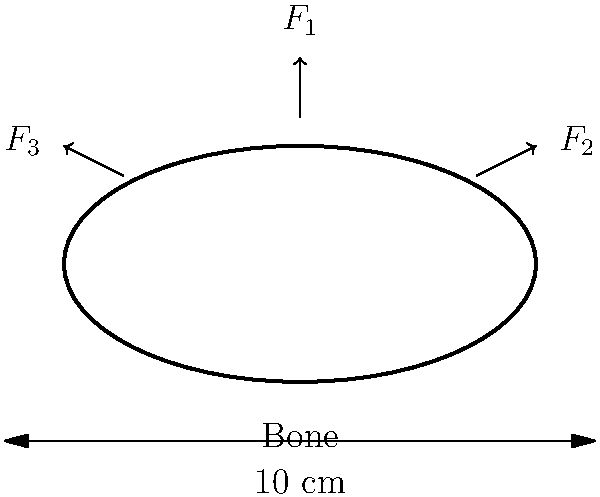A cross-sectional view of a bone is shown above, with three forces acting on it: a vertical force $F_1 = 500$ N, and two lateral forces $F_2 = F_3 = 250$ N. If the bone has a cross-sectional area of 5 cm² and a moment of inertia of 0.8 cm⁴, calculate the maximum normal stress $\sigma_{max}$ in the bone. Assume the bone behaves as a linear elastic material. To solve this problem, we'll follow these steps:

1) First, we need to calculate the total axial force and bending moment:
   Axial force: $F_{axial} = F_1 = 500$ N
   Bending moment: $M = F_2 \cdot d = F_3 \cdot d = 250 \text{ N} \cdot 0.04 \text{ m} = 10 \text{ N}\cdot\text{m}$

2) The normal stress due to axial force is:
   $$\sigma_{axial} = \frac{F_{axial}}{A} = \frac{500 \text{ N}}{5 \times 10^{-4} \text{ m}^2} = 1 \times 10^6 \text{ Pa} = 1 \text{ MPa}$$

3) The maximum bending stress is:
   $$\sigma_{bending} = \frac{My}{I}$$
   where $y$ is the distance from the neutral axis to the outermost fiber (2 cm in this case).
   $$\sigma_{bending} = \frac{10 \text{ N}\cdot\text{m} \cdot 0.02 \text{ m}}{0.8 \times 10^{-8} \text{ m}^4} = 25 \times 10^6 \text{ Pa} = 25 \text{ MPa}$$

4) The maximum normal stress is the sum of axial and bending stresses:
   $$\sigma_{max} = \sigma_{axial} + \sigma_{bending} = 1 \text{ MPa} + 25 \text{ MPa} = 26 \text{ MPa}$$
Answer: 26 MPa 